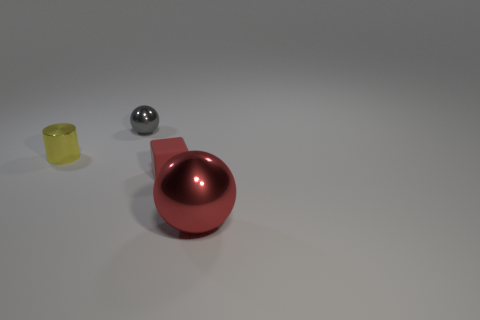Can you describe the materials of the objects present? Certainly! In the image, there are objects that seem to be made of various materials. The large red ball has a reflective, smooth surface which suggests it's made of a polished metal or plastic. The small gray ball also has a reflective surface, indicative of a metallic material, while the yellow cup appears to have a matte finish, consistent with plastic or ceramic. 